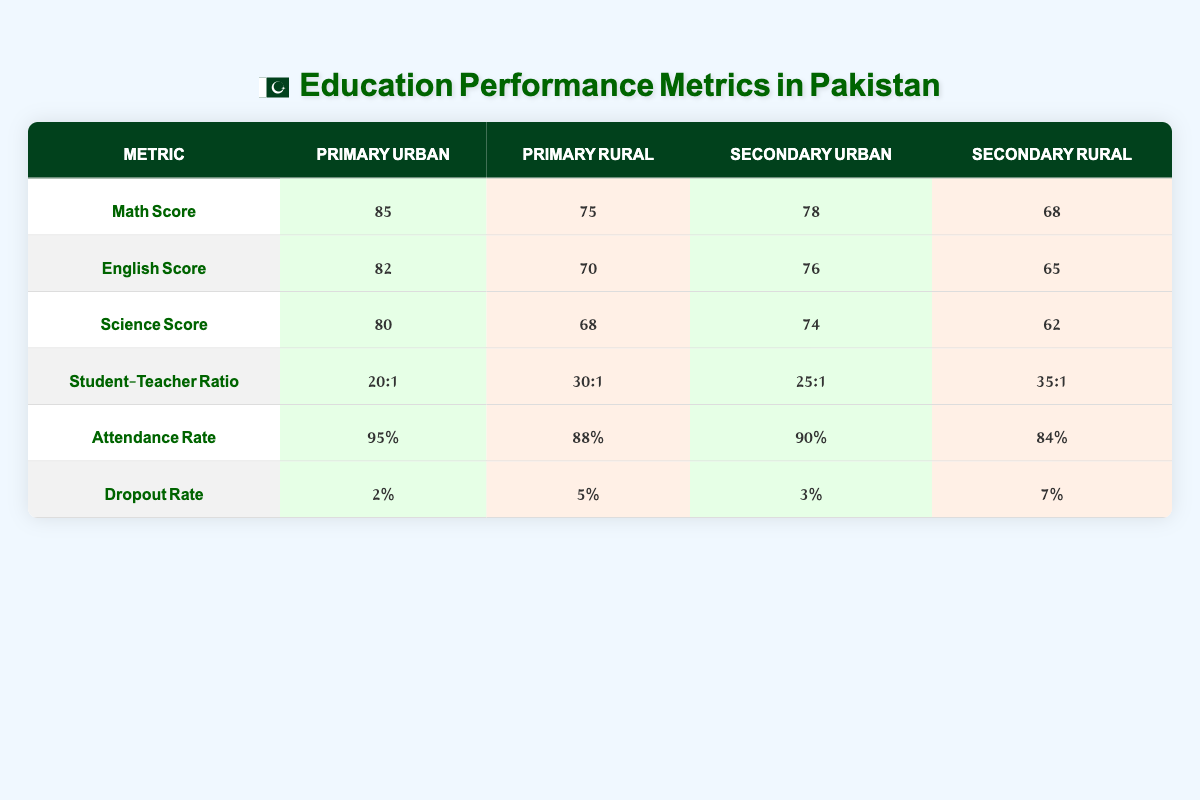What is the average Math test score for Primary education in Urban areas? The table shows that the average Math test score for Primary education in Urban areas is 85.
Answer: 85 What is the Student-Teacher Ratio for Secondary education in Rural areas? The table lists the Student-Teacher Ratio for Secondary education in Rural areas as 35:1.
Answer: 35:1 Is the Attendance Rate higher in Urban or Rural areas for Primary education? The Attendance Rate for Primary education in Urban areas is 95%, while in Rural areas it is 88%. Since 95% is greater than 88%, the Attendance Rate is higher in Urban areas.
Answer: Yes What is the difference in Science test scores between Primary education in Urban and Rural areas? The Science test score for Primary in Urban areas is 80, and for Rural areas, it is 68. The difference is 80 - 68 = 12.
Answer: 12 What percentage of students drop out of Secondary education in Rural areas? The table states that the dropout rate for Secondary education in Rural areas is 7%.
Answer: 7% How does the English test score in Urban areas for Secondary education compare to the score in Rural areas? The English test score for Secondary education in Urban areas is 76, while in Rural areas it is 65. The Urban score is higher by 76 - 65 = 11.
Answer: Higher by 11 What is the average Attendance Rate in Urban areas for both Primary and Secondary education? The Attendance Rate for Primary education in Urban areas is 95% and for Secondary education it is 90%. The average is (95% + 90%) / 2 = 92.5%.
Answer: 92.5% In which education level is the dropout rate lower in Urban areas? The dropout rate for Urban Primary education is 2%, and for Urban Secondary education, it is 3%. Since 2% is less than 3%, it is lower in Primary education.
Answer: Primary education 